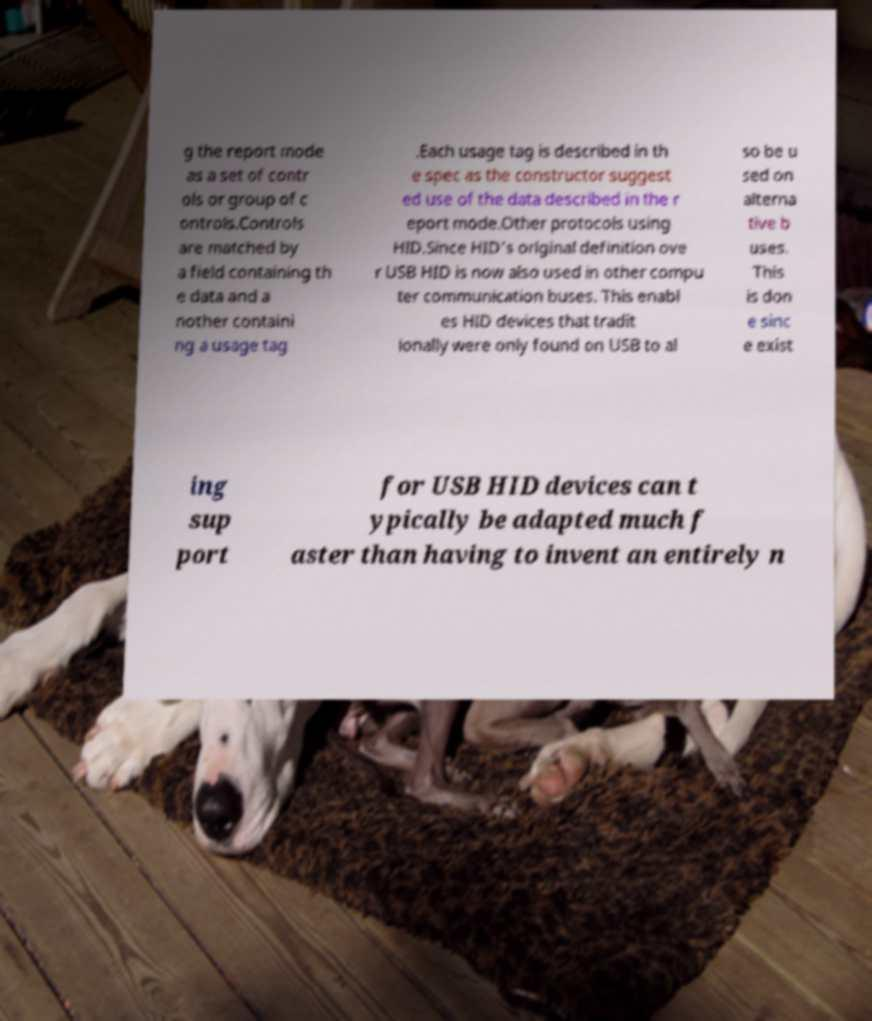Please read and relay the text visible in this image. What does it say? g the report mode as a set of contr ols or group of c ontrols.Controls are matched by a field containing th e data and a nother containi ng a usage tag .Each usage tag is described in th e spec as the constructor suggest ed use of the data described in the r eport mode.Other protocols using HID.Since HID's original definition ove r USB HID is now also used in other compu ter communication buses. This enabl es HID devices that tradit ionally were only found on USB to al so be u sed on alterna tive b uses. This is don e sinc e exist ing sup port for USB HID devices can t ypically be adapted much f aster than having to invent an entirely n 